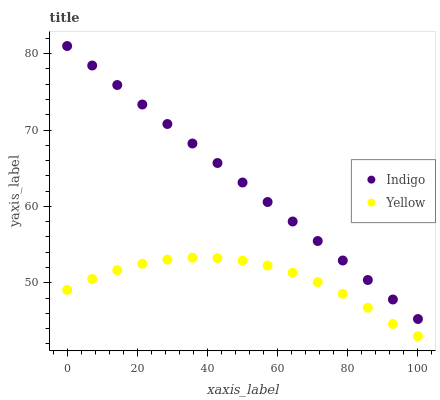Does Yellow have the minimum area under the curve?
Answer yes or no. Yes. Does Indigo have the maximum area under the curve?
Answer yes or no. Yes. Does Yellow have the maximum area under the curve?
Answer yes or no. No. Is Indigo the smoothest?
Answer yes or no. Yes. Is Yellow the roughest?
Answer yes or no. Yes. Is Yellow the smoothest?
Answer yes or no. No. Does Yellow have the lowest value?
Answer yes or no. Yes. Does Indigo have the highest value?
Answer yes or no. Yes. Does Yellow have the highest value?
Answer yes or no. No. Is Yellow less than Indigo?
Answer yes or no. Yes. Is Indigo greater than Yellow?
Answer yes or no. Yes. Does Yellow intersect Indigo?
Answer yes or no. No. 